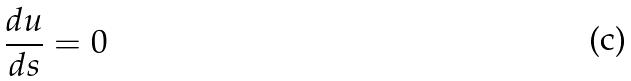Convert formula to latex. <formula><loc_0><loc_0><loc_500><loc_500>\frac { d u } { d s } = 0</formula> 